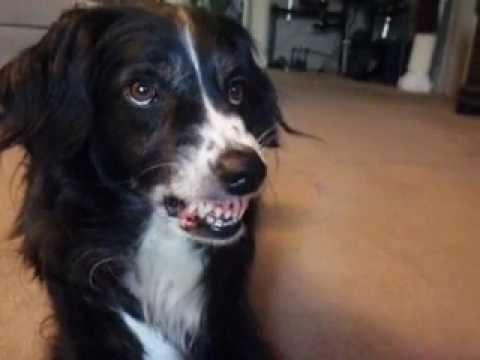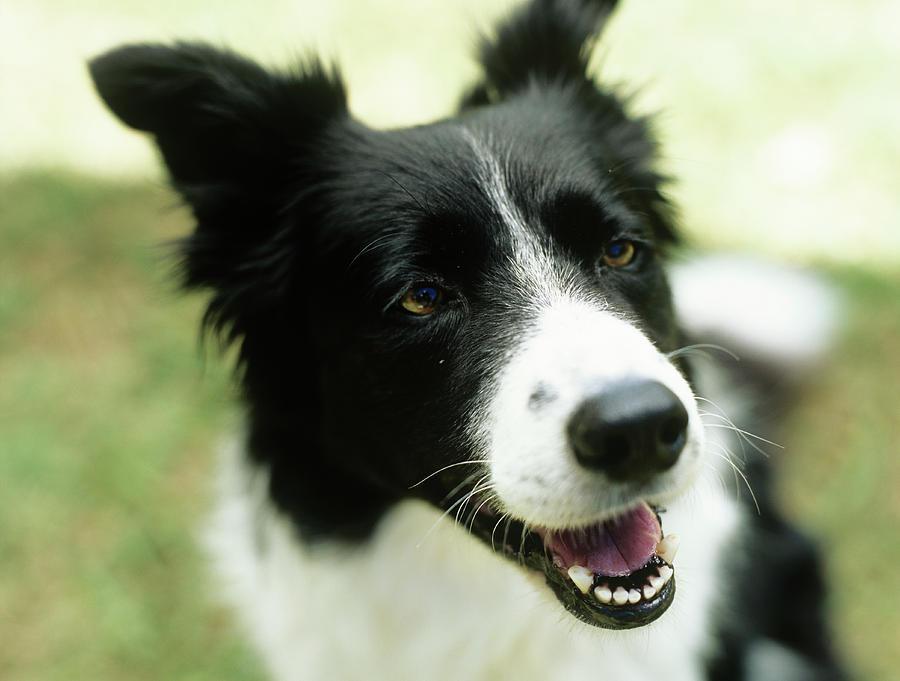The first image is the image on the left, the second image is the image on the right. For the images displayed, is the sentence "Both dogs are barring their teeth in aggression." factually correct? Answer yes or no. No. 